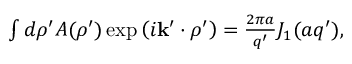Convert formula to latex. <formula><loc_0><loc_0><loc_500><loc_500>\begin{array} { r } { \int d \rho ^ { \prime } A ( \rho ^ { \prime } ) \exp \left ( i k ^ { \prime } \cdot \rho ^ { \prime } \right ) = \frac { 2 \pi a } { q ^ { \prime } } J _ { 1 } ( a q ^ { \prime } ) , } \end{array}</formula> 